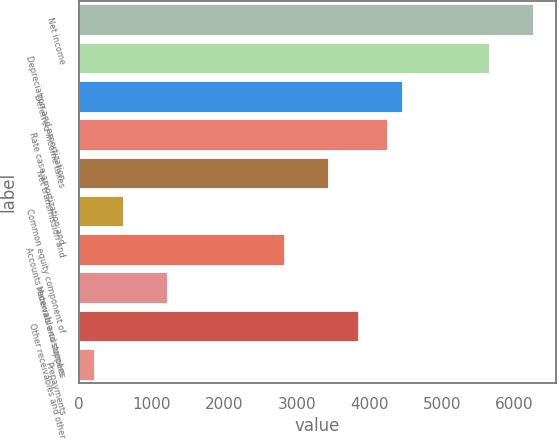<chart> <loc_0><loc_0><loc_500><loc_500><bar_chart><fcel>Net income<fcel>Depreciation and amortization<fcel>Deferred income taxes<fcel>Rate case amortization and<fcel>Net transmission and<fcel>Common equity component of<fcel>Accounts receivable-customers<fcel>Materials and supplies<fcel>Other receivables and other<fcel>Prepayments<nl><fcel>6260.9<fcel>5655.2<fcel>4443.8<fcel>4241.9<fcel>3434.3<fcel>607.7<fcel>2828.6<fcel>1213.4<fcel>3838.1<fcel>203.9<nl></chart> 